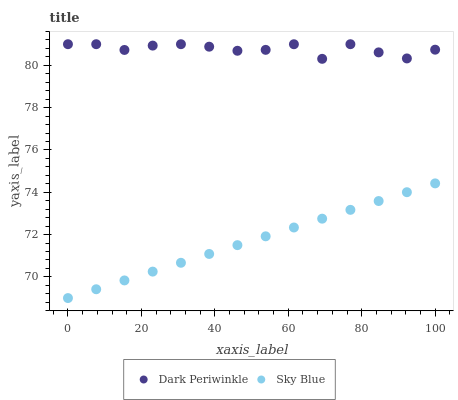Does Sky Blue have the minimum area under the curve?
Answer yes or no. Yes. Does Dark Periwinkle have the maximum area under the curve?
Answer yes or no. Yes. Does Dark Periwinkle have the minimum area under the curve?
Answer yes or no. No. Is Sky Blue the smoothest?
Answer yes or no. Yes. Is Dark Periwinkle the roughest?
Answer yes or no. Yes. Is Dark Periwinkle the smoothest?
Answer yes or no. No. Does Sky Blue have the lowest value?
Answer yes or no. Yes. Does Dark Periwinkle have the lowest value?
Answer yes or no. No. Does Dark Periwinkle have the highest value?
Answer yes or no. Yes. Is Sky Blue less than Dark Periwinkle?
Answer yes or no. Yes. Is Dark Periwinkle greater than Sky Blue?
Answer yes or no. Yes. Does Sky Blue intersect Dark Periwinkle?
Answer yes or no. No. 